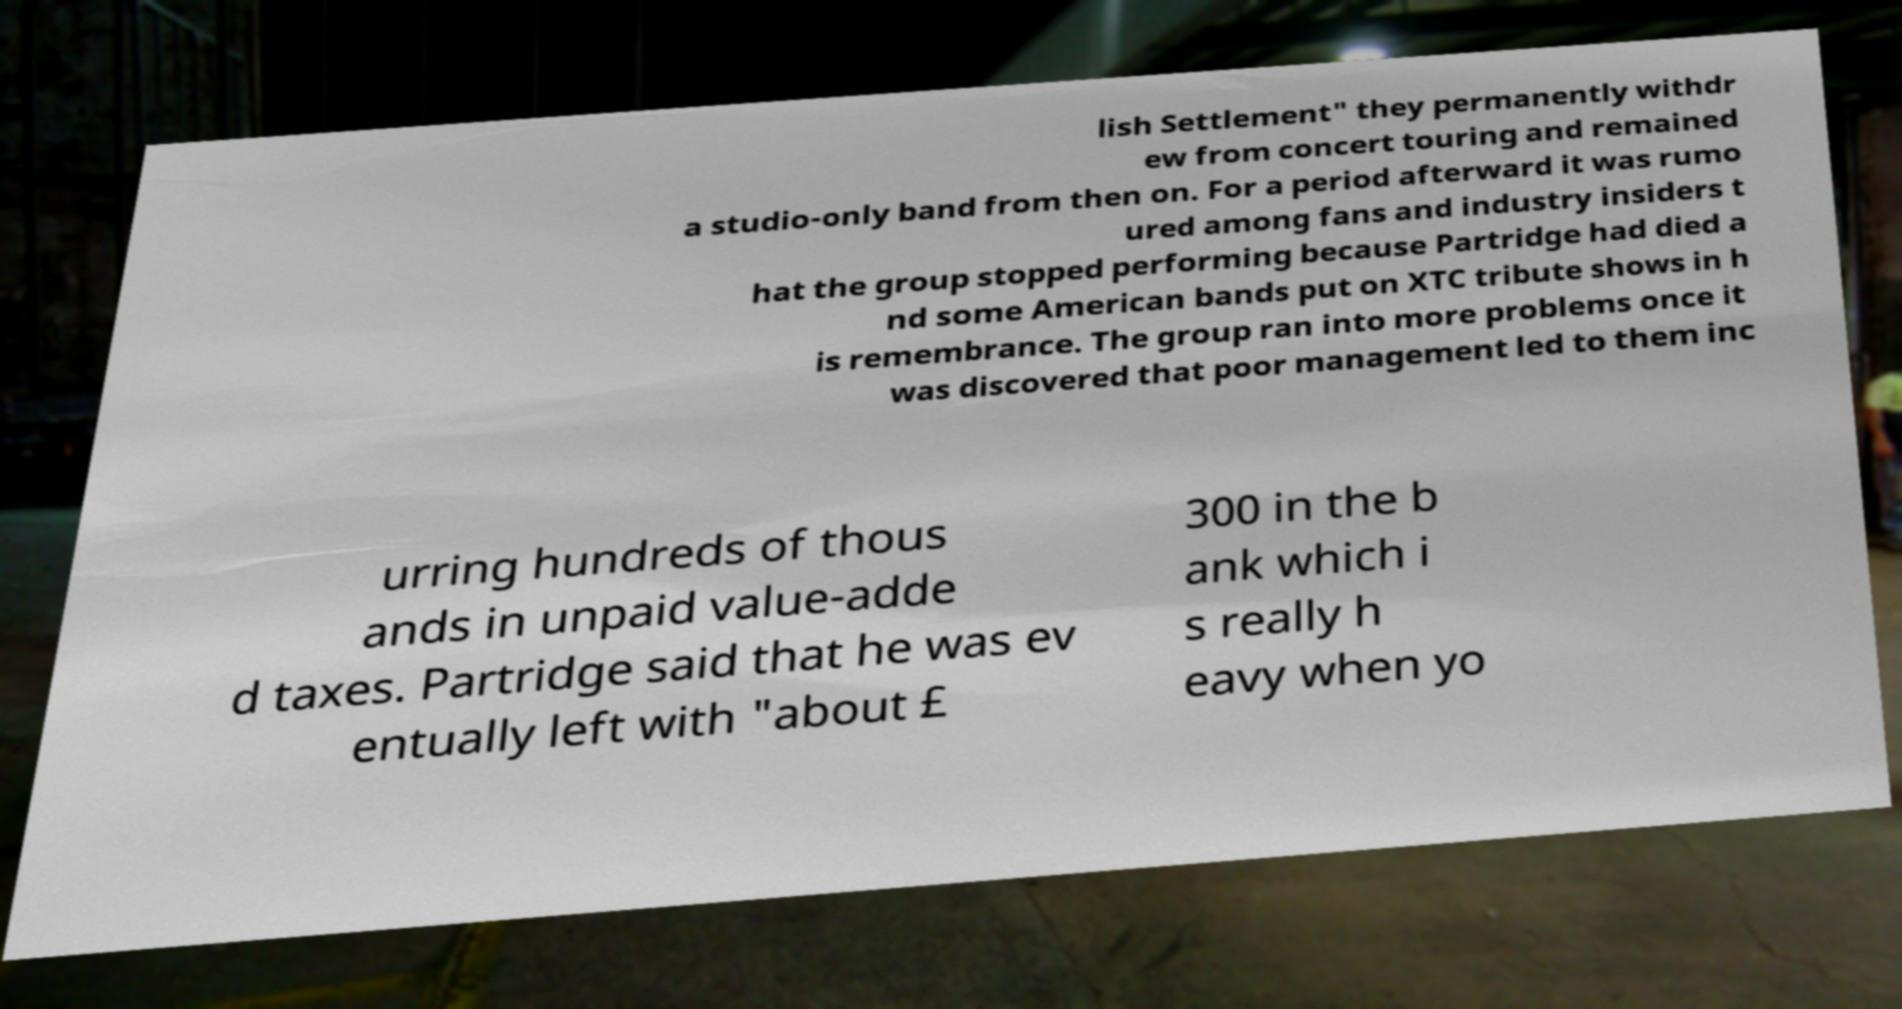Please identify and transcribe the text found in this image. lish Settlement" they permanently withdr ew from concert touring and remained a studio-only band from then on. For a period afterward it was rumo ured among fans and industry insiders t hat the group stopped performing because Partridge had died a nd some American bands put on XTC tribute shows in h is remembrance. The group ran into more problems once it was discovered that poor management led to them inc urring hundreds of thous ands in unpaid value-adde d taxes. Partridge said that he was ev entually left with "about £ 300 in the b ank which i s really h eavy when yo 